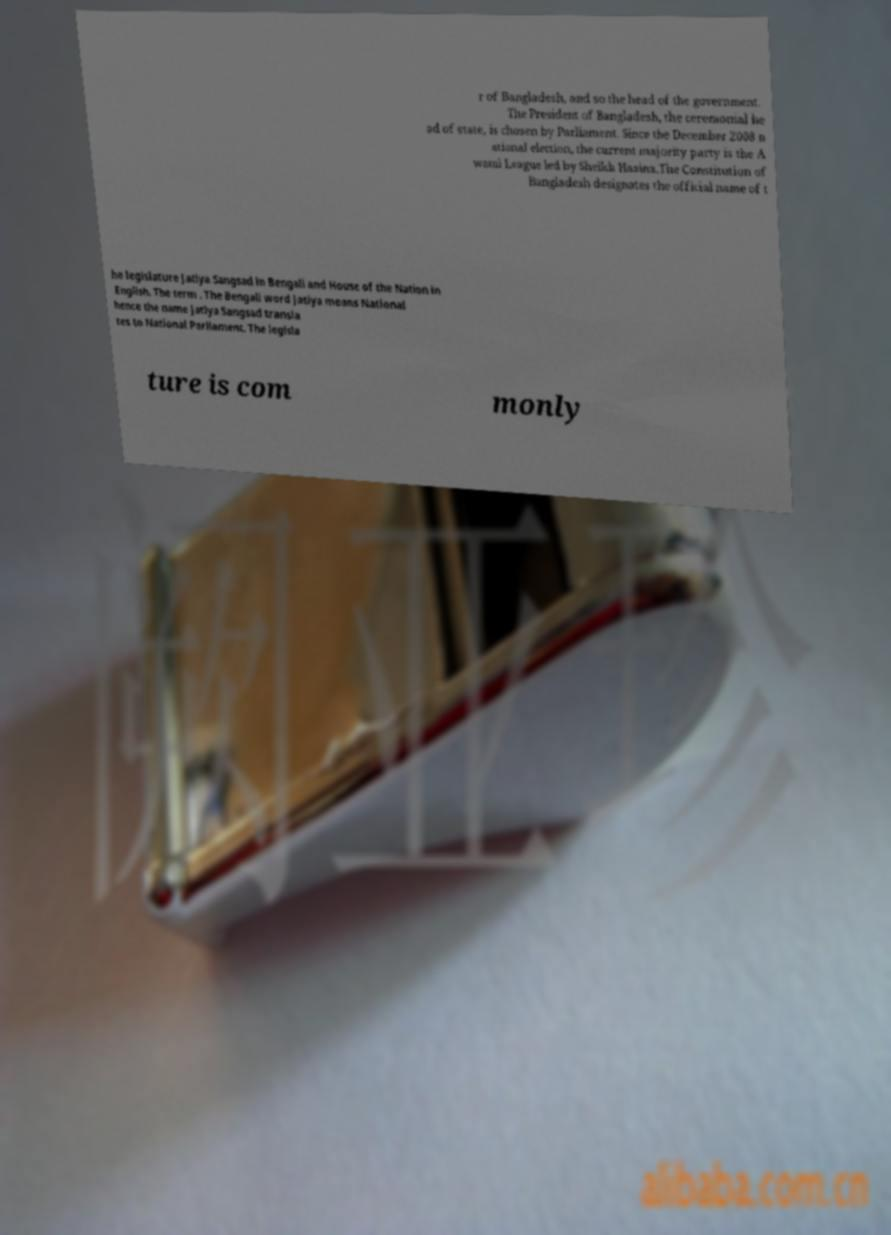Can you read and provide the text displayed in the image?This photo seems to have some interesting text. Can you extract and type it out for me? r of Bangladesh, and so the head of the government. The President of Bangladesh, the ceremonial he ad of state, is chosen by Parliament. Since the December 2008 n ational election, the current majority party is the A wami League led by Sheikh Hasina.The Constitution of Bangladesh designates the official name of t he legislature Jatiya Sangsad in Bengali and House of the Nation in English. The term . The Bengali word Jatiya means National hence the name Jatiya Sangsad transla tes to National Parliament. The legisla ture is com monly 